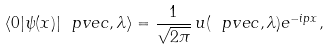Convert formula to latex. <formula><loc_0><loc_0><loc_500><loc_500>\langle 0 | \psi ( x ) | \ p v e c , \lambda \rangle = \frac { 1 } { \sqrt { 2 \pi } } \, u ( \ p v e c , \lambda ) e ^ { - i p x } ,</formula> 